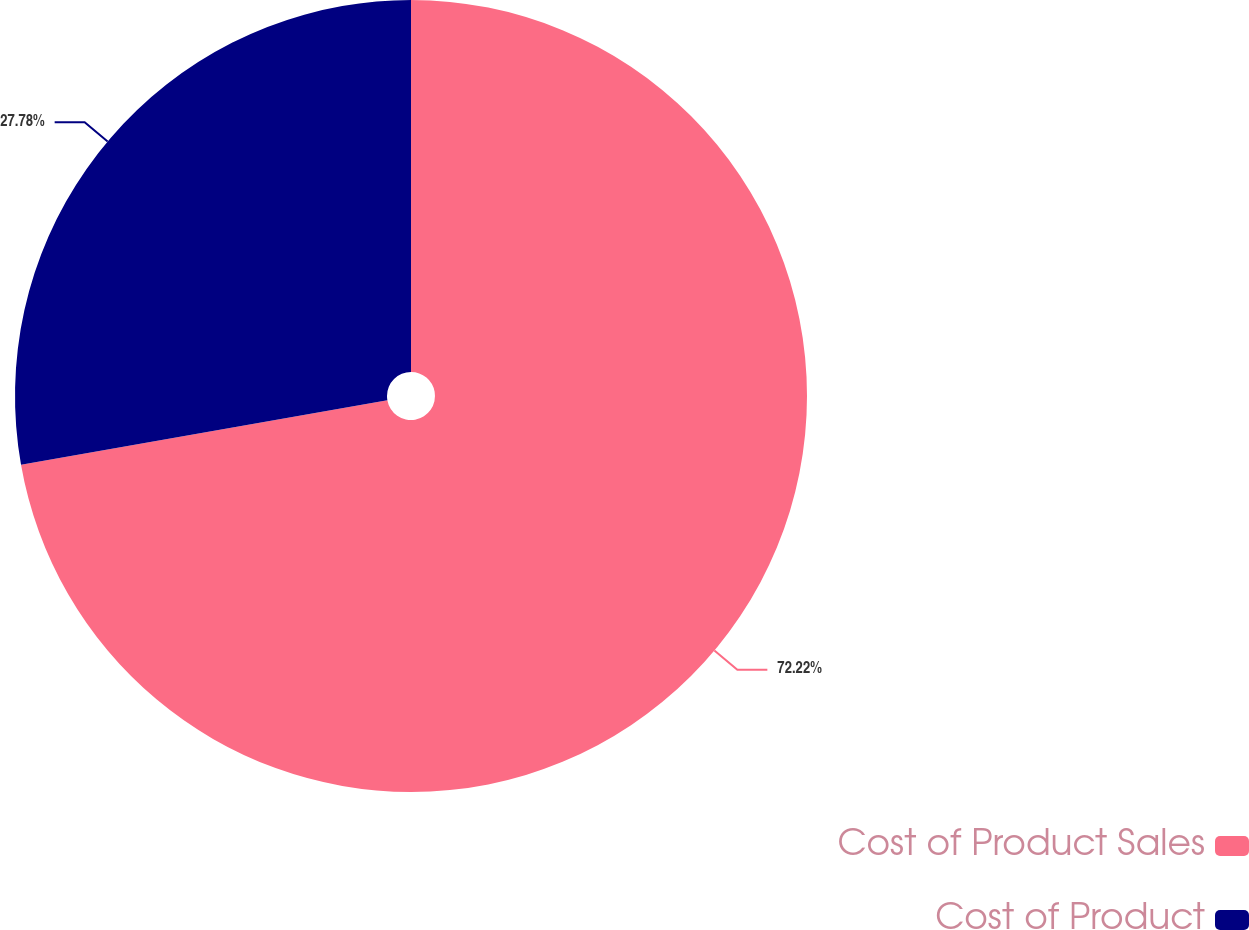Convert chart to OTSL. <chart><loc_0><loc_0><loc_500><loc_500><pie_chart><fcel>Cost of Product Sales<fcel>Cost of Product<nl><fcel>72.22%<fcel>27.78%<nl></chart> 